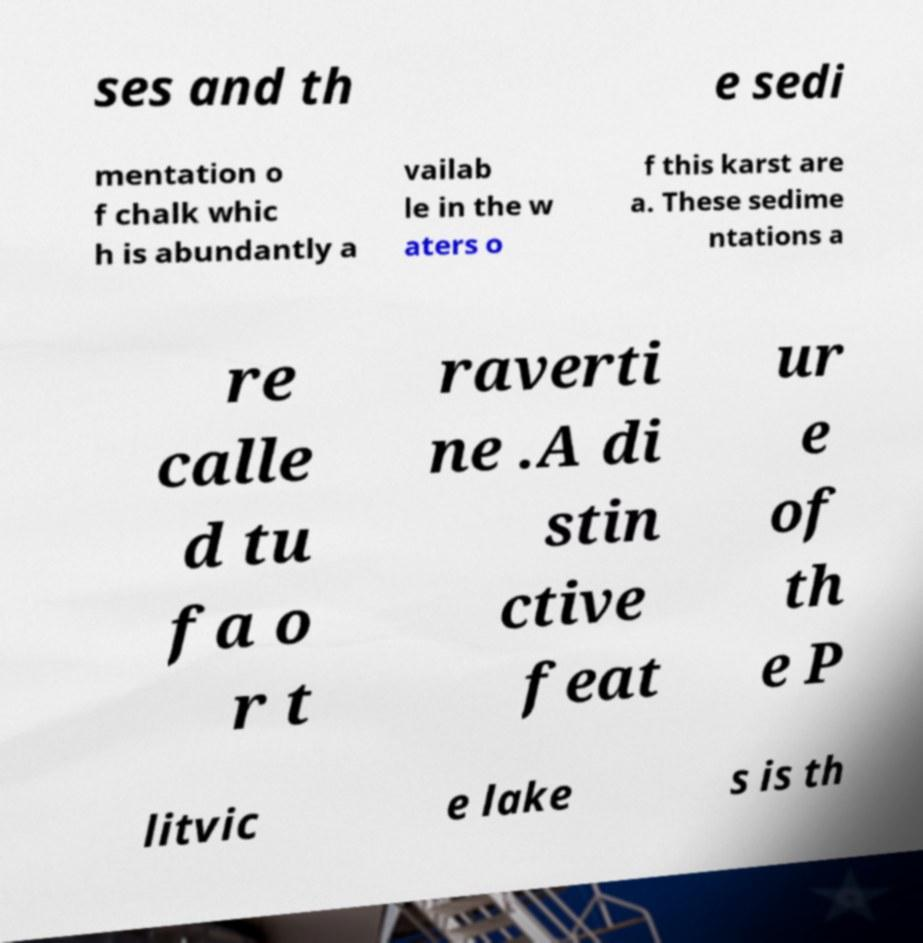Can you accurately transcribe the text from the provided image for me? ses and th e sedi mentation o f chalk whic h is abundantly a vailab le in the w aters o f this karst are a. These sedime ntations a re calle d tu fa o r t raverti ne .A di stin ctive feat ur e of th e P litvic e lake s is th 